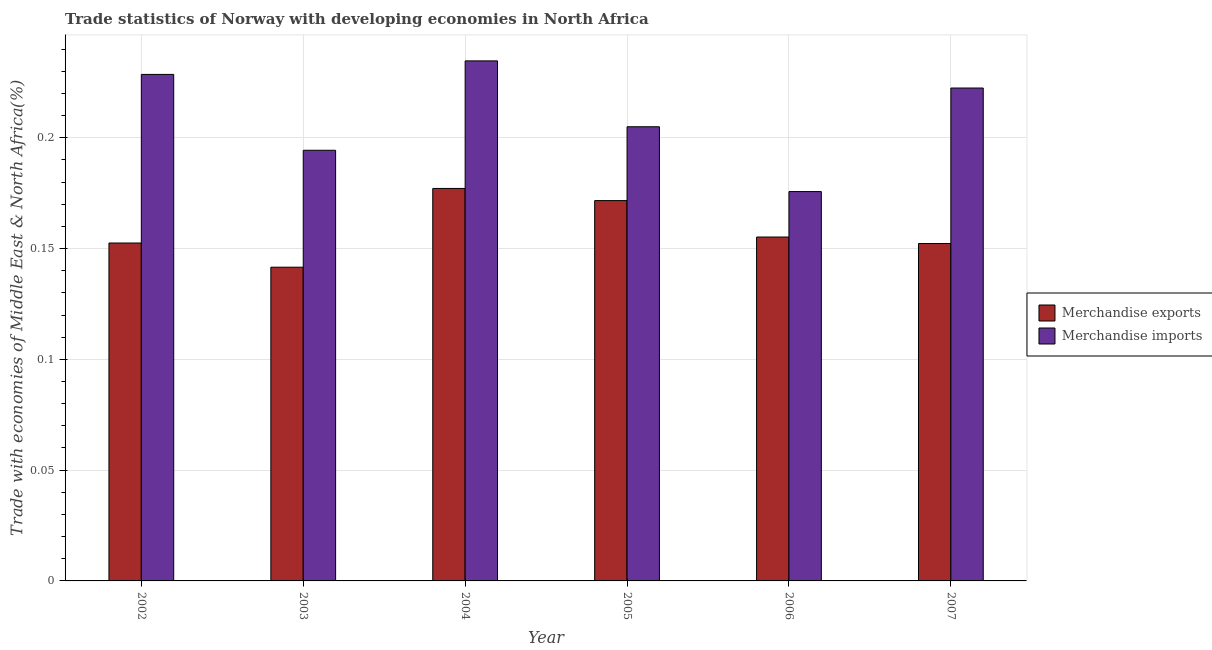How many different coloured bars are there?
Offer a terse response. 2. Are the number of bars on each tick of the X-axis equal?
Keep it short and to the point. Yes. How many bars are there on the 6th tick from the right?
Your answer should be very brief. 2. In how many cases, is the number of bars for a given year not equal to the number of legend labels?
Your response must be concise. 0. What is the merchandise exports in 2004?
Make the answer very short. 0.18. Across all years, what is the maximum merchandise exports?
Give a very brief answer. 0.18. Across all years, what is the minimum merchandise exports?
Your response must be concise. 0.14. In which year was the merchandise exports maximum?
Provide a succinct answer. 2004. What is the total merchandise imports in the graph?
Offer a very short reply. 1.26. What is the difference between the merchandise exports in 2003 and that in 2006?
Your answer should be compact. -0.01. What is the difference between the merchandise exports in 2004 and the merchandise imports in 2007?
Your answer should be compact. 0.02. What is the average merchandise exports per year?
Ensure brevity in your answer.  0.16. What is the ratio of the merchandise imports in 2002 to that in 2007?
Keep it short and to the point. 1.03. Is the difference between the merchandise imports in 2002 and 2003 greater than the difference between the merchandise exports in 2002 and 2003?
Provide a succinct answer. No. What is the difference between the highest and the second highest merchandise exports?
Provide a succinct answer. 0.01. What is the difference between the highest and the lowest merchandise exports?
Your answer should be very brief. 0.04. What does the 1st bar from the left in 2003 represents?
Offer a very short reply. Merchandise exports. How many years are there in the graph?
Give a very brief answer. 6. Does the graph contain any zero values?
Your response must be concise. No. How many legend labels are there?
Keep it short and to the point. 2. How are the legend labels stacked?
Give a very brief answer. Vertical. What is the title of the graph?
Provide a short and direct response. Trade statistics of Norway with developing economies in North Africa. What is the label or title of the X-axis?
Ensure brevity in your answer.  Year. What is the label or title of the Y-axis?
Keep it short and to the point. Trade with economies of Middle East & North Africa(%). What is the Trade with economies of Middle East & North Africa(%) of Merchandise exports in 2002?
Give a very brief answer. 0.15. What is the Trade with economies of Middle East & North Africa(%) of Merchandise imports in 2002?
Make the answer very short. 0.23. What is the Trade with economies of Middle East & North Africa(%) in Merchandise exports in 2003?
Offer a very short reply. 0.14. What is the Trade with economies of Middle East & North Africa(%) in Merchandise imports in 2003?
Give a very brief answer. 0.19. What is the Trade with economies of Middle East & North Africa(%) of Merchandise exports in 2004?
Keep it short and to the point. 0.18. What is the Trade with economies of Middle East & North Africa(%) in Merchandise imports in 2004?
Your response must be concise. 0.23. What is the Trade with economies of Middle East & North Africa(%) in Merchandise exports in 2005?
Provide a succinct answer. 0.17. What is the Trade with economies of Middle East & North Africa(%) in Merchandise imports in 2005?
Make the answer very short. 0.2. What is the Trade with economies of Middle East & North Africa(%) of Merchandise exports in 2006?
Ensure brevity in your answer.  0.16. What is the Trade with economies of Middle East & North Africa(%) of Merchandise imports in 2006?
Your answer should be very brief. 0.18. What is the Trade with economies of Middle East & North Africa(%) in Merchandise exports in 2007?
Provide a succinct answer. 0.15. What is the Trade with economies of Middle East & North Africa(%) in Merchandise imports in 2007?
Make the answer very short. 0.22. Across all years, what is the maximum Trade with economies of Middle East & North Africa(%) in Merchandise exports?
Make the answer very short. 0.18. Across all years, what is the maximum Trade with economies of Middle East & North Africa(%) in Merchandise imports?
Your answer should be compact. 0.23. Across all years, what is the minimum Trade with economies of Middle East & North Africa(%) in Merchandise exports?
Offer a very short reply. 0.14. Across all years, what is the minimum Trade with economies of Middle East & North Africa(%) of Merchandise imports?
Keep it short and to the point. 0.18. What is the total Trade with economies of Middle East & North Africa(%) of Merchandise exports in the graph?
Your response must be concise. 0.95. What is the total Trade with economies of Middle East & North Africa(%) in Merchandise imports in the graph?
Give a very brief answer. 1.26. What is the difference between the Trade with economies of Middle East & North Africa(%) of Merchandise exports in 2002 and that in 2003?
Your answer should be very brief. 0.01. What is the difference between the Trade with economies of Middle East & North Africa(%) of Merchandise imports in 2002 and that in 2003?
Provide a short and direct response. 0.03. What is the difference between the Trade with economies of Middle East & North Africa(%) in Merchandise exports in 2002 and that in 2004?
Give a very brief answer. -0.02. What is the difference between the Trade with economies of Middle East & North Africa(%) in Merchandise imports in 2002 and that in 2004?
Make the answer very short. -0.01. What is the difference between the Trade with economies of Middle East & North Africa(%) in Merchandise exports in 2002 and that in 2005?
Your response must be concise. -0.02. What is the difference between the Trade with economies of Middle East & North Africa(%) of Merchandise imports in 2002 and that in 2005?
Make the answer very short. 0.02. What is the difference between the Trade with economies of Middle East & North Africa(%) of Merchandise exports in 2002 and that in 2006?
Provide a succinct answer. -0. What is the difference between the Trade with economies of Middle East & North Africa(%) in Merchandise imports in 2002 and that in 2006?
Your answer should be compact. 0.05. What is the difference between the Trade with economies of Middle East & North Africa(%) of Merchandise exports in 2002 and that in 2007?
Provide a succinct answer. 0. What is the difference between the Trade with economies of Middle East & North Africa(%) in Merchandise imports in 2002 and that in 2007?
Offer a terse response. 0.01. What is the difference between the Trade with economies of Middle East & North Africa(%) of Merchandise exports in 2003 and that in 2004?
Your answer should be compact. -0.04. What is the difference between the Trade with economies of Middle East & North Africa(%) in Merchandise imports in 2003 and that in 2004?
Make the answer very short. -0.04. What is the difference between the Trade with economies of Middle East & North Africa(%) in Merchandise exports in 2003 and that in 2005?
Give a very brief answer. -0.03. What is the difference between the Trade with economies of Middle East & North Africa(%) in Merchandise imports in 2003 and that in 2005?
Your answer should be very brief. -0.01. What is the difference between the Trade with economies of Middle East & North Africa(%) in Merchandise exports in 2003 and that in 2006?
Keep it short and to the point. -0.01. What is the difference between the Trade with economies of Middle East & North Africa(%) in Merchandise imports in 2003 and that in 2006?
Your answer should be very brief. 0.02. What is the difference between the Trade with economies of Middle East & North Africa(%) in Merchandise exports in 2003 and that in 2007?
Your answer should be compact. -0.01. What is the difference between the Trade with economies of Middle East & North Africa(%) in Merchandise imports in 2003 and that in 2007?
Ensure brevity in your answer.  -0.03. What is the difference between the Trade with economies of Middle East & North Africa(%) of Merchandise exports in 2004 and that in 2005?
Your response must be concise. 0.01. What is the difference between the Trade with economies of Middle East & North Africa(%) of Merchandise imports in 2004 and that in 2005?
Offer a terse response. 0.03. What is the difference between the Trade with economies of Middle East & North Africa(%) of Merchandise exports in 2004 and that in 2006?
Offer a terse response. 0.02. What is the difference between the Trade with economies of Middle East & North Africa(%) in Merchandise imports in 2004 and that in 2006?
Keep it short and to the point. 0.06. What is the difference between the Trade with economies of Middle East & North Africa(%) in Merchandise exports in 2004 and that in 2007?
Offer a very short reply. 0.02. What is the difference between the Trade with economies of Middle East & North Africa(%) in Merchandise imports in 2004 and that in 2007?
Provide a succinct answer. 0.01. What is the difference between the Trade with economies of Middle East & North Africa(%) of Merchandise exports in 2005 and that in 2006?
Your answer should be compact. 0.02. What is the difference between the Trade with economies of Middle East & North Africa(%) of Merchandise imports in 2005 and that in 2006?
Give a very brief answer. 0.03. What is the difference between the Trade with economies of Middle East & North Africa(%) in Merchandise exports in 2005 and that in 2007?
Make the answer very short. 0.02. What is the difference between the Trade with economies of Middle East & North Africa(%) in Merchandise imports in 2005 and that in 2007?
Offer a terse response. -0.02. What is the difference between the Trade with economies of Middle East & North Africa(%) of Merchandise exports in 2006 and that in 2007?
Keep it short and to the point. 0. What is the difference between the Trade with economies of Middle East & North Africa(%) in Merchandise imports in 2006 and that in 2007?
Provide a short and direct response. -0.05. What is the difference between the Trade with economies of Middle East & North Africa(%) in Merchandise exports in 2002 and the Trade with economies of Middle East & North Africa(%) in Merchandise imports in 2003?
Provide a short and direct response. -0.04. What is the difference between the Trade with economies of Middle East & North Africa(%) in Merchandise exports in 2002 and the Trade with economies of Middle East & North Africa(%) in Merchandise imports in 2004?
Keep it short and to the point. -0.08. What is the difference between the Trade with economies of Middle East & North Africa(%) of Merchandise exports in 2002 and the Trade with economies of Middle East & North Africa(%) of Merchandise imports in 2005?
Offer a very short reply. -0.05. What is the difference between the Trade with economies of Middle East & North Africa(%) of Merchandise exports in 2002 and the Trade with economies of Middle East & North Africa(%) of Merchandise imports in 2006?
Provide a succinct answer. -0.02. What is the difference between the Trade with economies of Middle East & North Africa(%) in Merchandise exports in 2002 and the Trade with economies of Middle East & North Africa(%) in Merchandise imports in 2007?
Your answer should be compact. -0.07. What is the difference between the Trade with economies of Middle East & North Africa(%) in Merchandise exports in 2003 and the Trade with economies of Middle East & North Africa(%) in Merchandise imports in 2004?
Your response must be concise. -0.09. What is the difference between the Trade with economies of Middle East & North Africa(%) of Merchandise exports in 2003 and the Trade with economies of Middle East & North Africa(%) of Merchandise imports in 2005?
Provide a succinct answer. -0.06. What is the difference between the Trade with economies of Middle East & North Africa(%) of Merchandise exports in 2003 and the Trade with economies of Middle East & North Africa(%) of Merchandise imports in 2006?
Keep it short and to the point. -0.03. What is the difference between the Trade with economies of Middle East & North Africa(%) in Merchandise exports in 2003 and the Trade with economies of Middle East & North Africa(%) in Merchandise imports in 2007?
Make the answer very short. -0.08. What is the difference between the Trade with economies of Middle East & North Africa(%) of Merchandise exports in 2004 and the Trade with economies of Middle East & North Africa(%) of Merchandise imports in 2005?
Your answer should be compact. -0.03. What is the difference between the Trade with economies of Middle East & North Africa(%) in Merchandise exports in 2004 and the Trade with economies of Middle East & North Africa(%) in Merchandise imports in 2006?
Your answer should be very brief. 0. What is the difference between the Trade with economies of Middle East & North Africa(%) in Merchandise exports in 2004 and the Trade with economies of Middle East & North Africa(%) in Merchandise imports in 2007?
Make the answer very short. -0.05. What is the difference between the Trade with economies of Middle East & North Africa(%) of Merchandise exports in 2005 and the Trade with economies of Middle East & North Africa(%) of Merchandise imports in 2006?
Make the answer very short. -0. What is the difference between the Trade with economies of Middle East & North Africa(%) of Merchandise exports in 2005 and the Trade with economies of Middle East & North Africa(%) of Merchandise imports in 2007?
Ensure brevity in your answer.  -0.05. What is the difference between the Trade with economies of Middle East & North Africa(%) in Merchandise exports in 2006 and the Trade with economies of Middle East & North Africa(%) in Merchandise imports in 2007?
Offer a very short reply. -0.07. What is the average Trade with economies of Middle East & North Africa(%) of Merchandise exports per year?
Give a very brief answer. 0.16. What is the average Trade with economies of Middle East & North Africa(%) of Merchandise imports per year?
Your response must be concise. 0.21. In the year 2002, what is the difference between the Trade with economies of Middle East & North Africa(%) in Merchandise exports and Trade with economies of Middle East & North Africa(%) in Merchandise imports?
Provide a short and direct response. -0.08. In the year 2003, what is the difference between the Trade with economies of Middle East & North Africa(%) of Merchandise exports and Trade with economies of Middle East & North Africa(%) of Merchandise imports?
Ensure brevity in your answer.  -0.05. In the year 2004, what is the difference between the Trade with economies of Middle East & North Africa(%) of Merchandise exports and Trade with economies of Middle East & North Africa(%) of Merchandise imports?
Your response must be concise. -0.06. In the year 2005, what is the difference between the Trade with economies of Middle East & North Africa(%) of Merchandise exports and Trade with economies of Middle East & North Africa(%) of Merchandise imports?
Keep it short and to the point. -0.03. In the year 2006, what is the difference between the Trade with economies of Middle East & North Africa(%) in Merchandise exports and Trade with economies of Middle East & North Africa(%) in Merchandise imports?
Offer a very short reply. -0.02. In the year 2007, what is the difference between the Trade with economies of Middle East & North Africa(%) in Merchandise exports and Trade with economies of Middle East & North Africa(%) in Merchandise imports?
Offer a terse response. -0.07. What is the ratio of the Trade with economies of Middle East & North Africa(%) of Merchandise exports in 2002 to that in 2003?
Offer a very short reply. 1.08. What is the ratio of the Trade with economies of Middle East & North Africa(%) in Merchandise imports in 2002 to that in 2003?
Offer a terse response. 1.18. What is the ratio of the Trade with economies of Middle East & North Africa(%) of Merchandise exports in 2002 to that in 2004?
Your answer should be compact. 0.86. What is the ratio of the Trade with economies of Middle East & North Africa(%) of Merchandise exports in 2002 to that in 2005?
Offer a very short reply. 0.89. What is the ratio of the Trade with economies of Middle East & North Africa(%) in Merchandise imports in 2002 to that in 2005?
Your answer should be very brief. 1.12. What is the ratio of the Trade with economies of Middle East & North Africa(%) in Merchandise exports in 2002 to that in 2006?
Offer a terse response. 0.98. What is the ratio of the Trade with economies of Middle East & North Africa(%) of Merchandise imports in 2002 to that in 2006?
Keep it short and to the point. 1.3. What is the ratio of the Trade with economies of Middle East & North Africa(%) of Merchandise exports in 2002 to that in 2007?
Give a very brief answer. 1. What is the ratio of the Trade with economies of Middle East & North Africa(%) of Merchandise imports in 2002 to that in 2007?
Ensure brevity in your answer.  1.03. What is the ratio of the Trade with economies of Middle East & North Africa(%) of Merchandise exports in 2003 to that in 2004?
Provide a succinct answer. 0.8. What is the ratio of the Trade with economies of Middle East & North Africa(%) of Merchandise imports in 2003 to that in 2004?
Your response must be concise. 0.83. What is the ratio of the Trade with economies of Middle East & North Africa(%) of Merchandise exports in 2003 to that in 2005?
Your answer should be compact. 0.82. What is the ratio of the Trade with economies of Middle East & North Africa(%) in Merchandise imports in 2003 to that in 2005?
Offer a terse response. 0.95. What is the ratio of the Trade with economies of Middle East & North Africa(%) in Merchandise exports in 2003 to that in 2006?
Ensure brevity in your answer.  0.91. What is the ratio of the Trade with economies of Middle East & North Africa(%) of Merchandise imports in 2003 to that in 2006?
Offer a terse response. 1.11. What is the ratio of the Trade with economies of Middle East & North Africa(%) in Merchandise exports in 2003 to that in 2007?
Provide a succinct answer. 0.93. What is the ratio of the Trade with economies of Middle East & North Africa(%) of Merchandise imports in 2003 to that in 2007?
Keep it short and to the point. 0.87. What is the ratio of the Trade with economies of Middle East & North Africa(%) in Merchandise exports in 2004 to that in 2005?
Your response must be concise. 1.03. What is the ratio of the Trade with economies of Middle East & North Africa(%) of Merchandise imports in 2004 to that in 2005?
Your answer should be compact. 1.15. What is the ratio of the Trade with economies of Middle East & North Africa(%) in Merchandise exports in 2004 to that in 2006?
Give a very brief answer. 1.14. What is the ratio of the Trade with economies of Middle East & North Africa(%) in Merchandise imports in 2004 to that in 2006?
Your response must be concise. 1.34. What is the ratio of the Trade with economies of Middle East & North Africa(%) of Merchandise exports in 2004 to that in 2007?
Offer a terse response. 1.16. What is the ratio of the Trade with economies of Middle East & North Africa(%) in Merchandise imports in 2004 to that in 2007?
Keep it short and to the point. 1.06. What is the ratio of the Trade with economies of Middle East & North Africa(%) in Merchandise exports in 2005 to that in 2006?
Your answer should be very brief. 1.11. What is the ratio of the Trade with economies of Middle East & North Africa(%) of Merchandise imports in 2005 to that in 2006?
Keep it short and to the point. 1.17. What is the ratio of the Trade with economies of Middle East & North Africa(%) of Merchandise exports in 2005 to that in 2007?
Your answer should be very brief. 1.13. What is the ratio of the Trade with economies of Middle East & North Africa(%) of Merchandise imports in 2005 to that in 2007?
Your response must be concise. 0.92. What is the ratio of the Trade with economies of Middle East & North Africa(%) of Merchandise exports in 2006 to that in 2007?
Provide a succinct answer. 1.02. What is the ratio of the Trade with economies of Middle East & North Africa(%) of Merchandise imports in 2006 to that in 2007?
Your response must be concise. 0.79. What is the difference between the highest and the second highest Trade with economies of Middle East & North Africa(%) in Merchandise exports?
Provide a short and direct response. 0.01. What is the difference between the highest and the second highest Trade with economies of Middle East & North Africa(%) in Merchandise imports?
Give a very brief answer. 0.01. What is the difference between the highest and the lowest Trade with economies of Middle East & North Africa(%) of Merchandise exports?
Keep it short and to the point. 0.04. What is the difference between the highest and the lowest Trade with economies of Middle East & North Africa(%) of Merchandise imports?
Your answer should be compact. 0.06. 